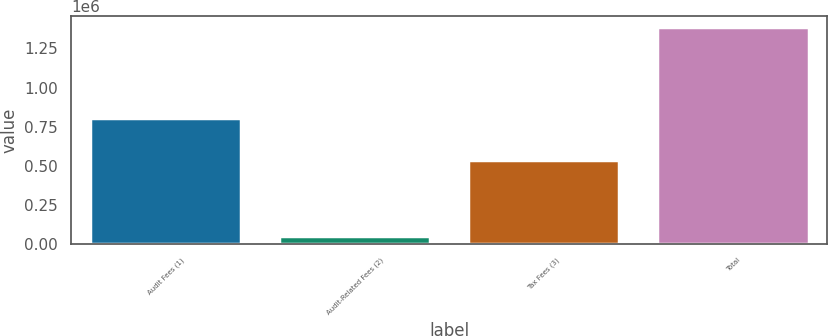Convert chart. <chart><loc_0><loc_0><loc_500><loc_500><bar_chart><fcel>Audit Fees (1)<fcel>Audit-Related Fees (2)<fcel>Tax Fees (3)<fcel>Total<nl><fcel>806145<fcel>48000<fcel>533828<fcel>1.38797e+06<nl></chart> 